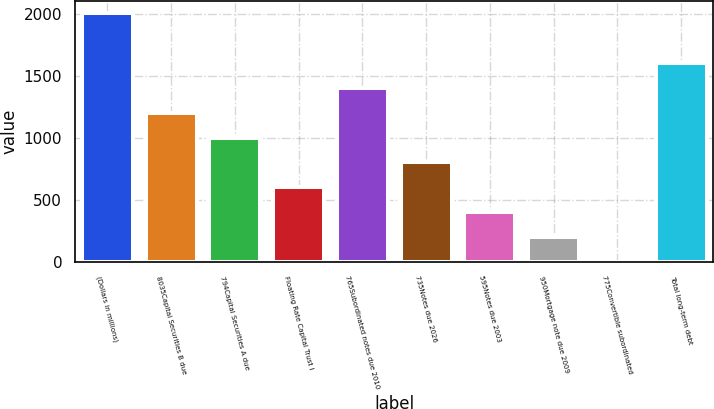<chart> <loc_0><loc_0><loc_500><loc_500><bar_chart><fcel>(Dollars in millions)<fcel>8035Capital Securities B due<fcel>794Capital Securities A due<fcel>Floating Rate Capital Trust I<fcel>765Subordinated notes due 2010<fcel>735Notes due 2026<fcel>595Notes due 2003<fcel>950Mortgage note due 2009<fcel>775Convertible subordinated<fcel>Total long-term debt<nl><fcel>2001<fcel>1201<fcel>1001<fcel>601<fcel>1401<fcel>801<fcel>401<fcel>201<fcel>1<fcel>1601<nl></chart> 